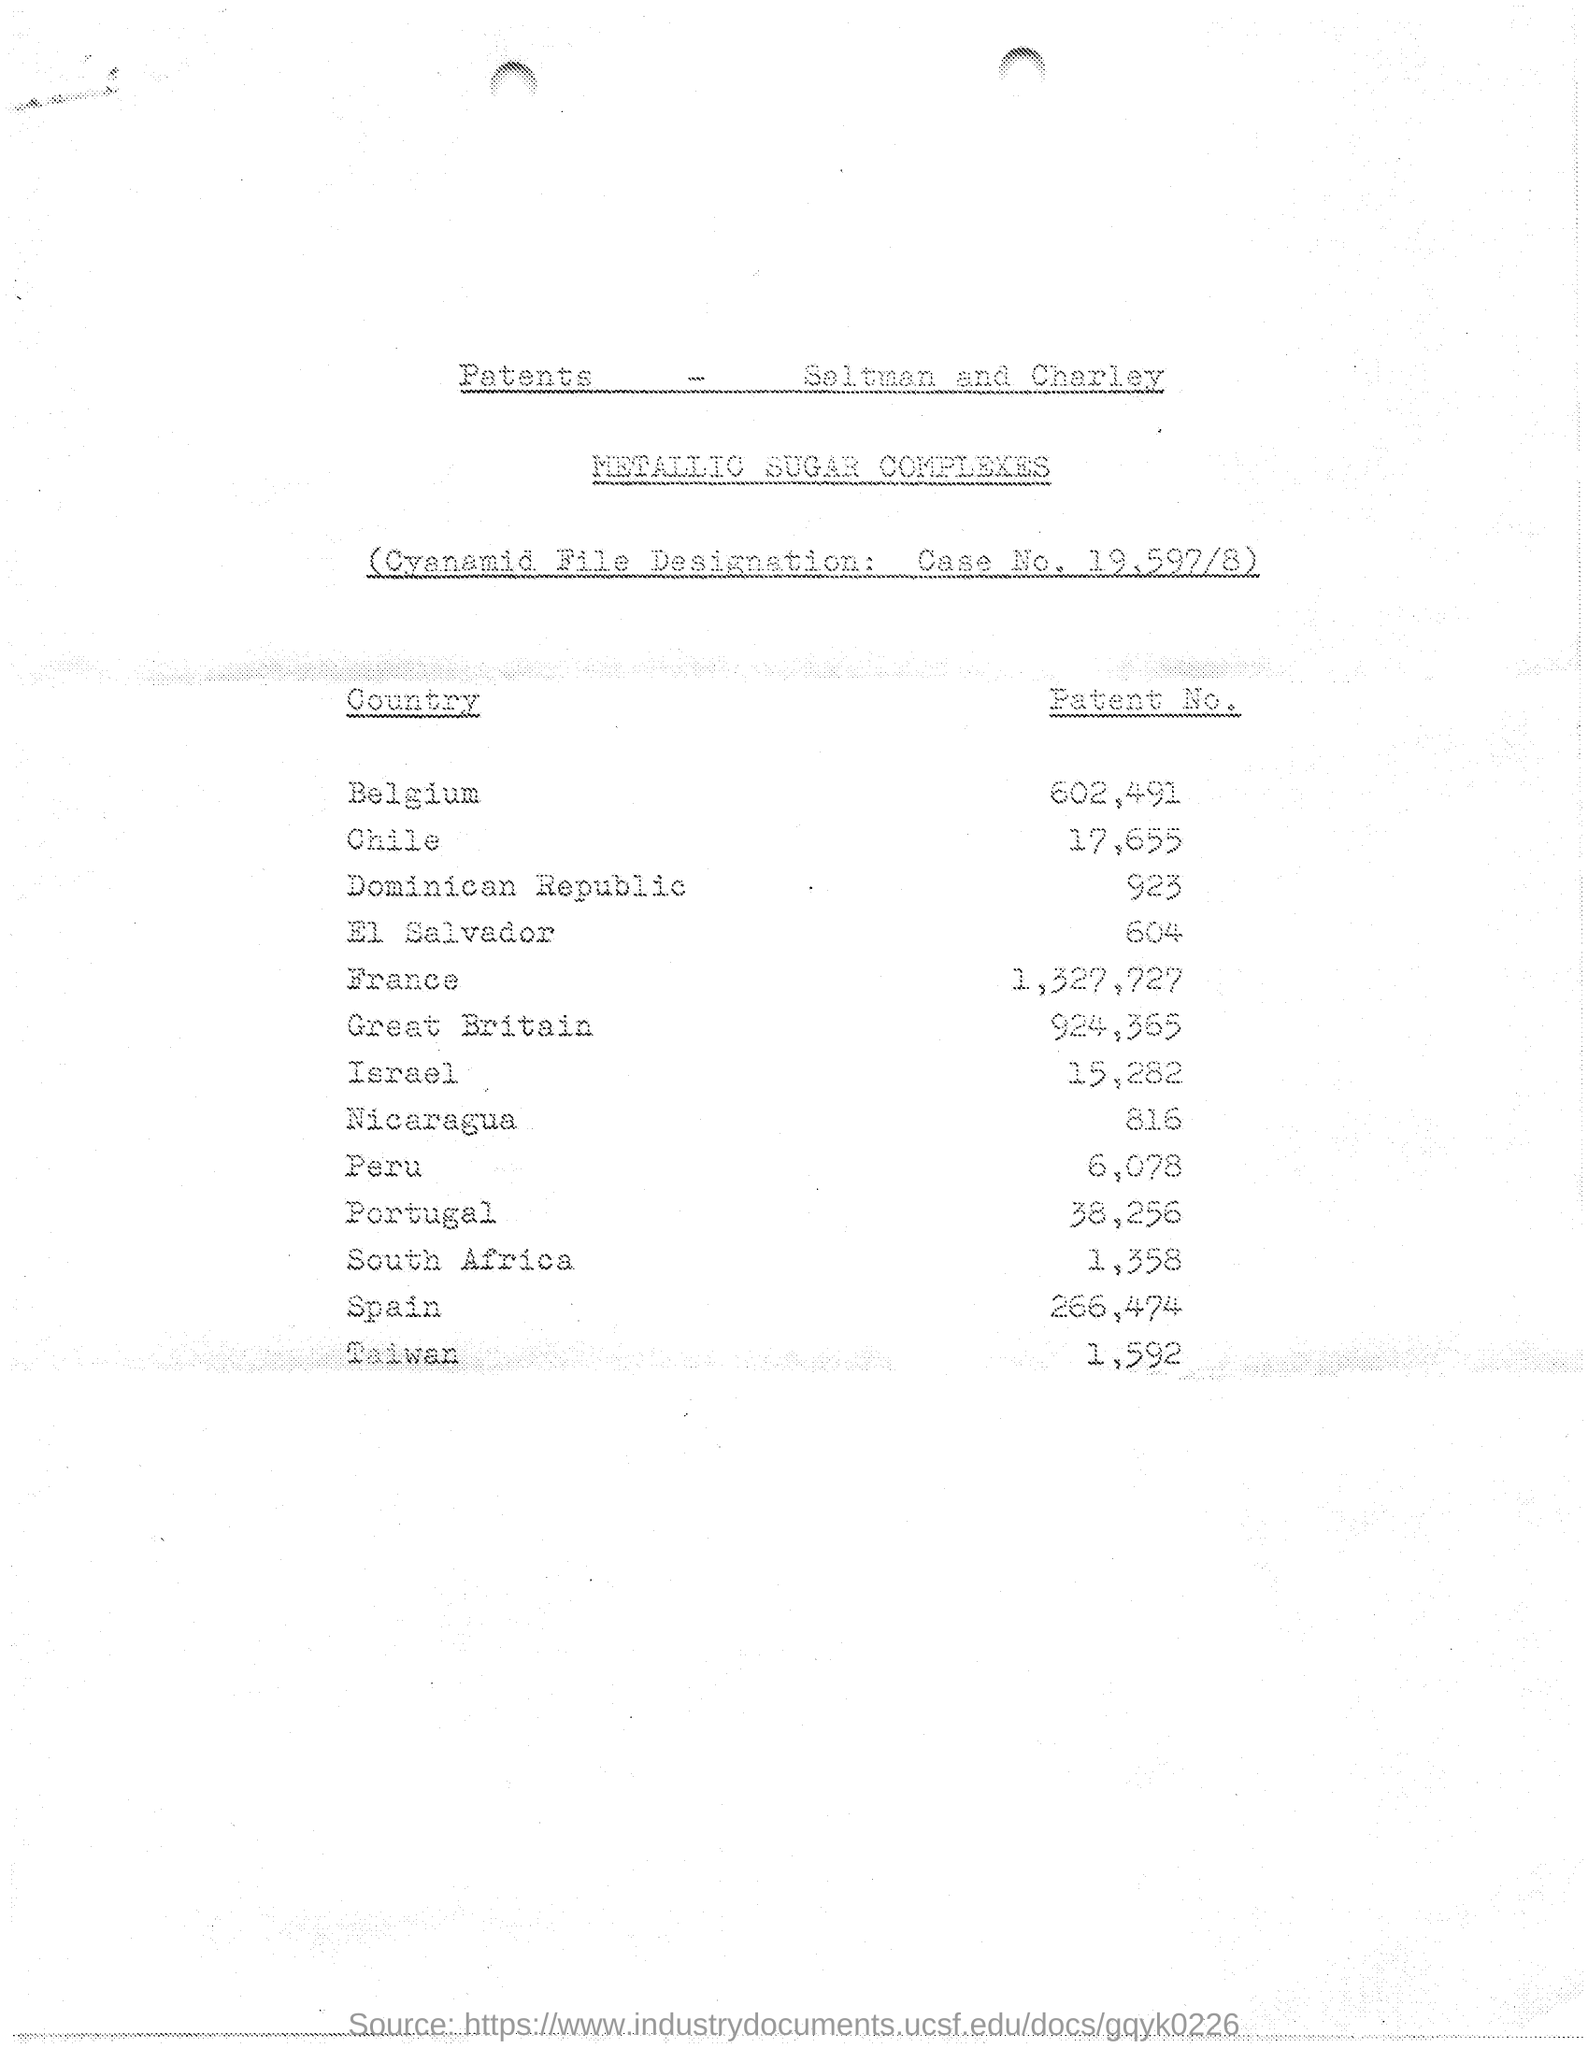What is number of patents in Belgium?
Provide a succinct answer. 602491. What is number of patents in chile?
Your response must be concise. 17,655. What is number of patents in France ?
Keep it short and to the point. 1,327,727. 